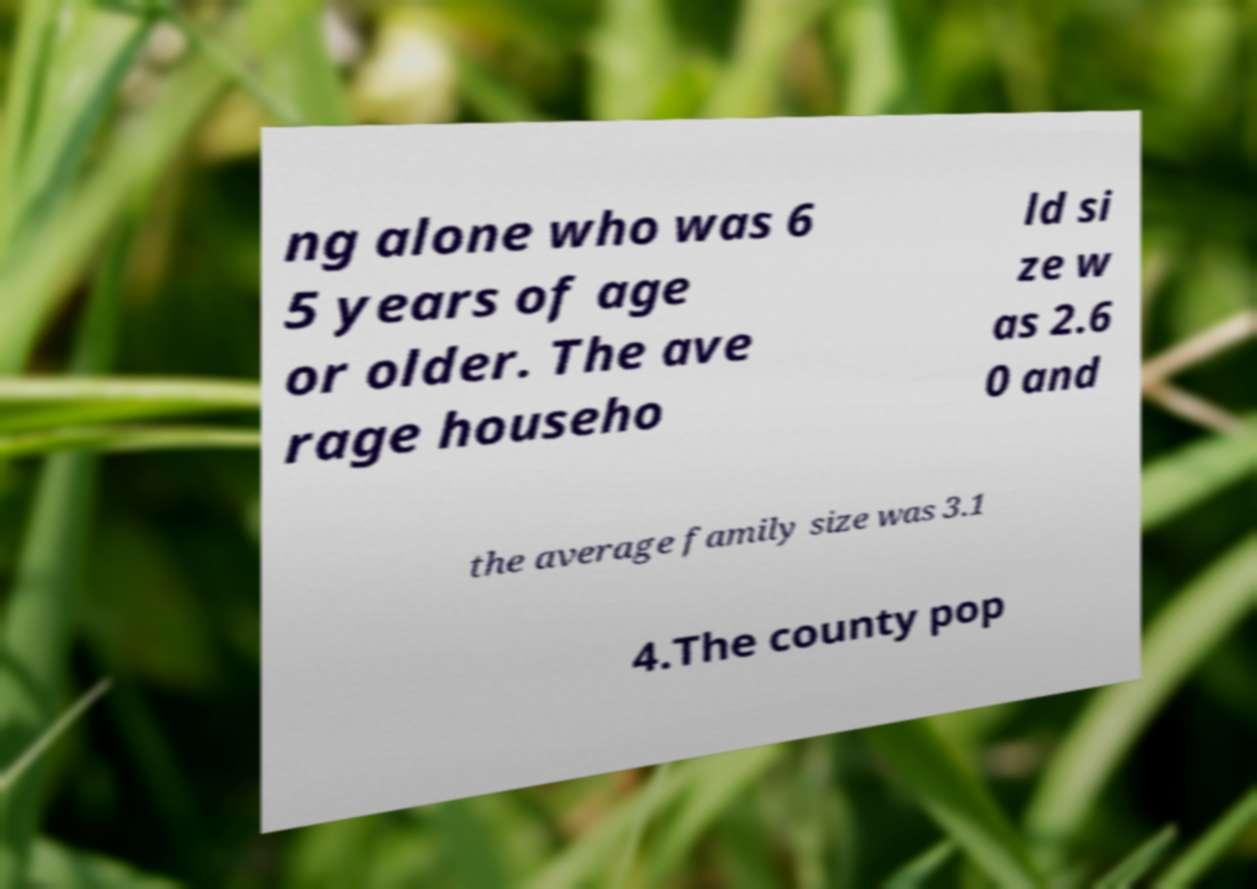Could you extract and type out the text from this image? ng alone who was 6 5 years of age or older. The ave rage househo ld si ze w as 2.6 0 and the average family size was 3.1 4.The county pop 